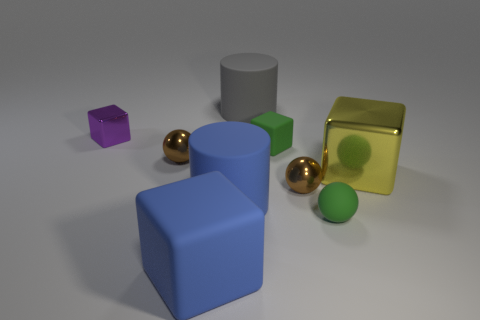Subtract all blue cylinders. How many brown balls are left? 2 Subtract all large yellow metallic cubes. How many cubes are left? 3 Subtract all gray cylinders. How many cylinders are left? 1 Subtract all cylinders. How many objects are left? 7 Subtract 2 cylinders. How many cylinders are left? 0 Add 2 rubber spheres. How many rubber spheres are left? 3 Add 6 green blocks. How many green blocks exist? 7 Subtract 0 cyan cubes. How many objects are left? 9 Subtract all blue cylinders. Subtract all gray cubes. How many cylinders are left? 1 Subtract all spheres. Subtract all big metallic blocks. How many objects are left? 5 